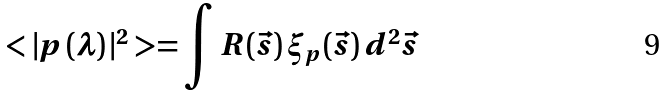Convert formula to latex. <formula><loc_0><loc_0><loc_500><loc_500>< | p \, ( \lambda ) \, | ^ { 2 } > = \int R ( \vec { s } ) \, \xi _ { p } ( \vec { s } ) \, d ^ { 2 } \vec { s }</formula> 